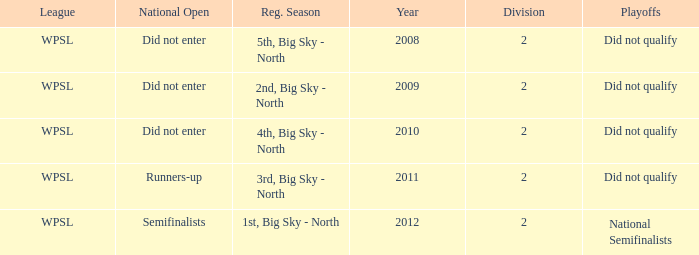What is the lowest division number? 2.0. 